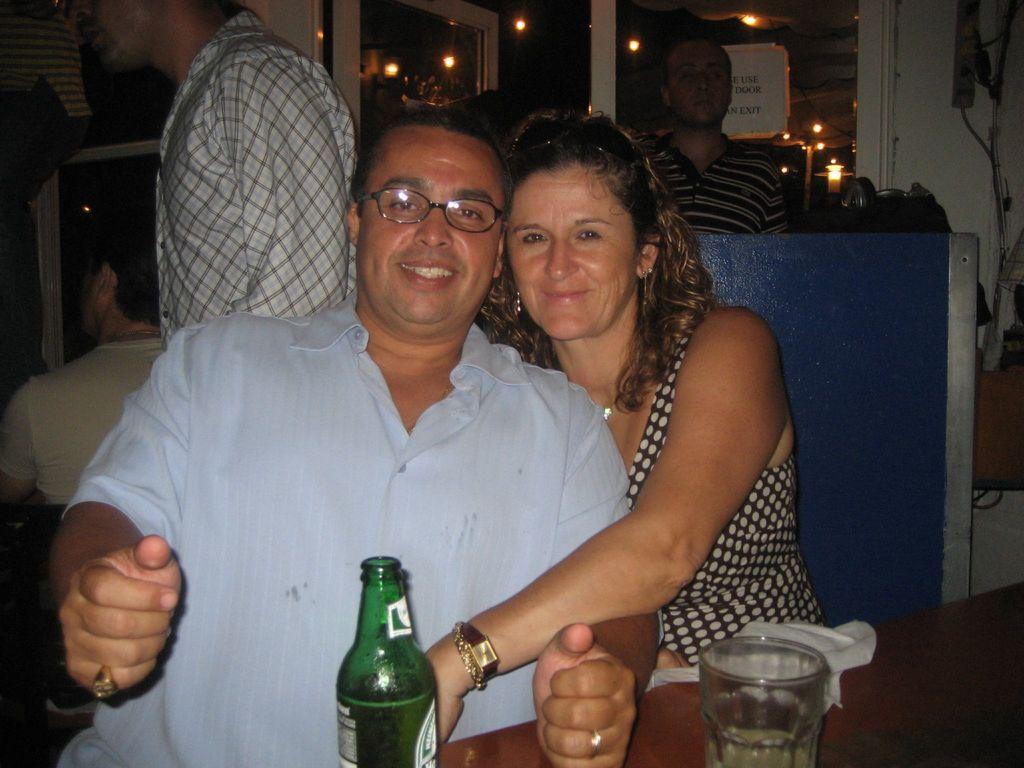Could you give a brief overview of what you see in this image? In this image I can see a man and women are sitting, I can also see smile on their faces and he is wearing a specs. Here on this table I can see a glass and a bottle. In the background I can see few more people. 